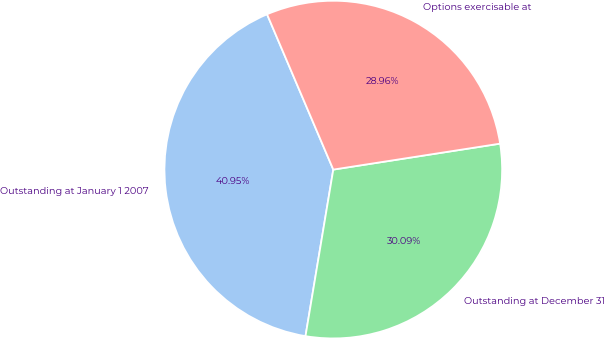Convert chart. <chart><loc_0><loc_0><loc_500><loc_500><pie_chart><fcel>Outstanding at January 1 2007<fcel>Outstanding at December 31<fcel>Options exercisable at<nl><fcel>40.95%<fcel>30.09%<fcel>28.96%<nl></chart> 